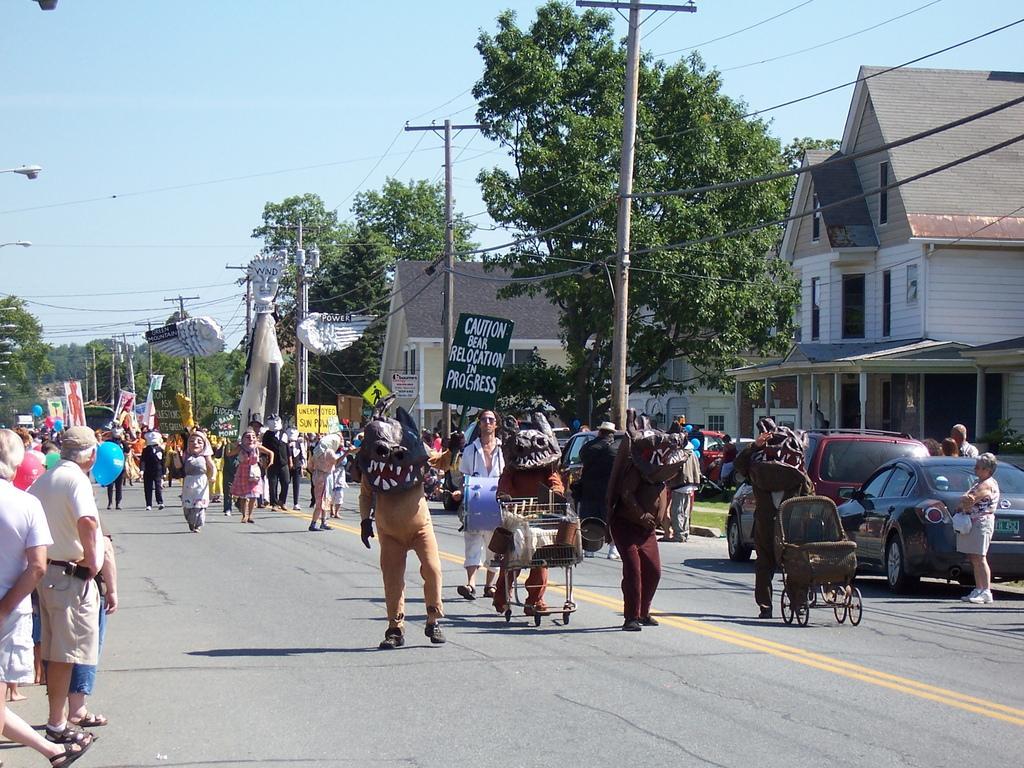Describe this image in one or two sentences. In this picture there are people, among them few people walking on the road and wore costumes and we can see cart, stroller and vehicles. We can see poles, lights, wires, houses, boards, grass, balloons and trees. In the background of the image we can see the sky. 